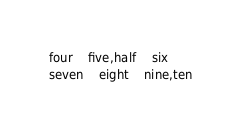Convert code to text. <code><loc_0><loc_0><loc_500><loc_500><_SQL_>four	five,half	six
seven	eight	nine,ten
</code> 